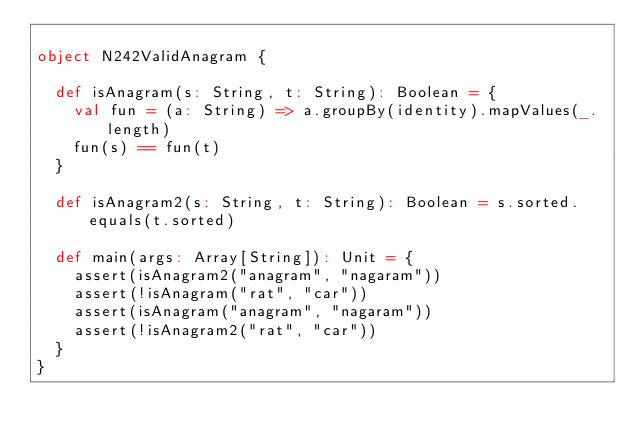<code> <loc_0><loc_0><loc_500><loc_500><_Scala_>
object N242ValidAnagram {

  def isAnagram(s: String, t: String): Boolean = {
    val fun = (a: String) => a.groupBy(identity).mapValues(_.length)
    fun(s) == fun(t)
  }

  def isAnagram2(s: String, t: String): Boolean = s.sorted.equals(t.sorted)

  def main(args: Array[String]): Unit = {
    assert(isAnagram2("anagram", "nagaram"))
    assert(!isAnagram("rat", "car"))
    assert(isAnagram("anagram", "nagaram"))
    assert(!isAnagram2("rat", "car"))
  }
}
</code> 